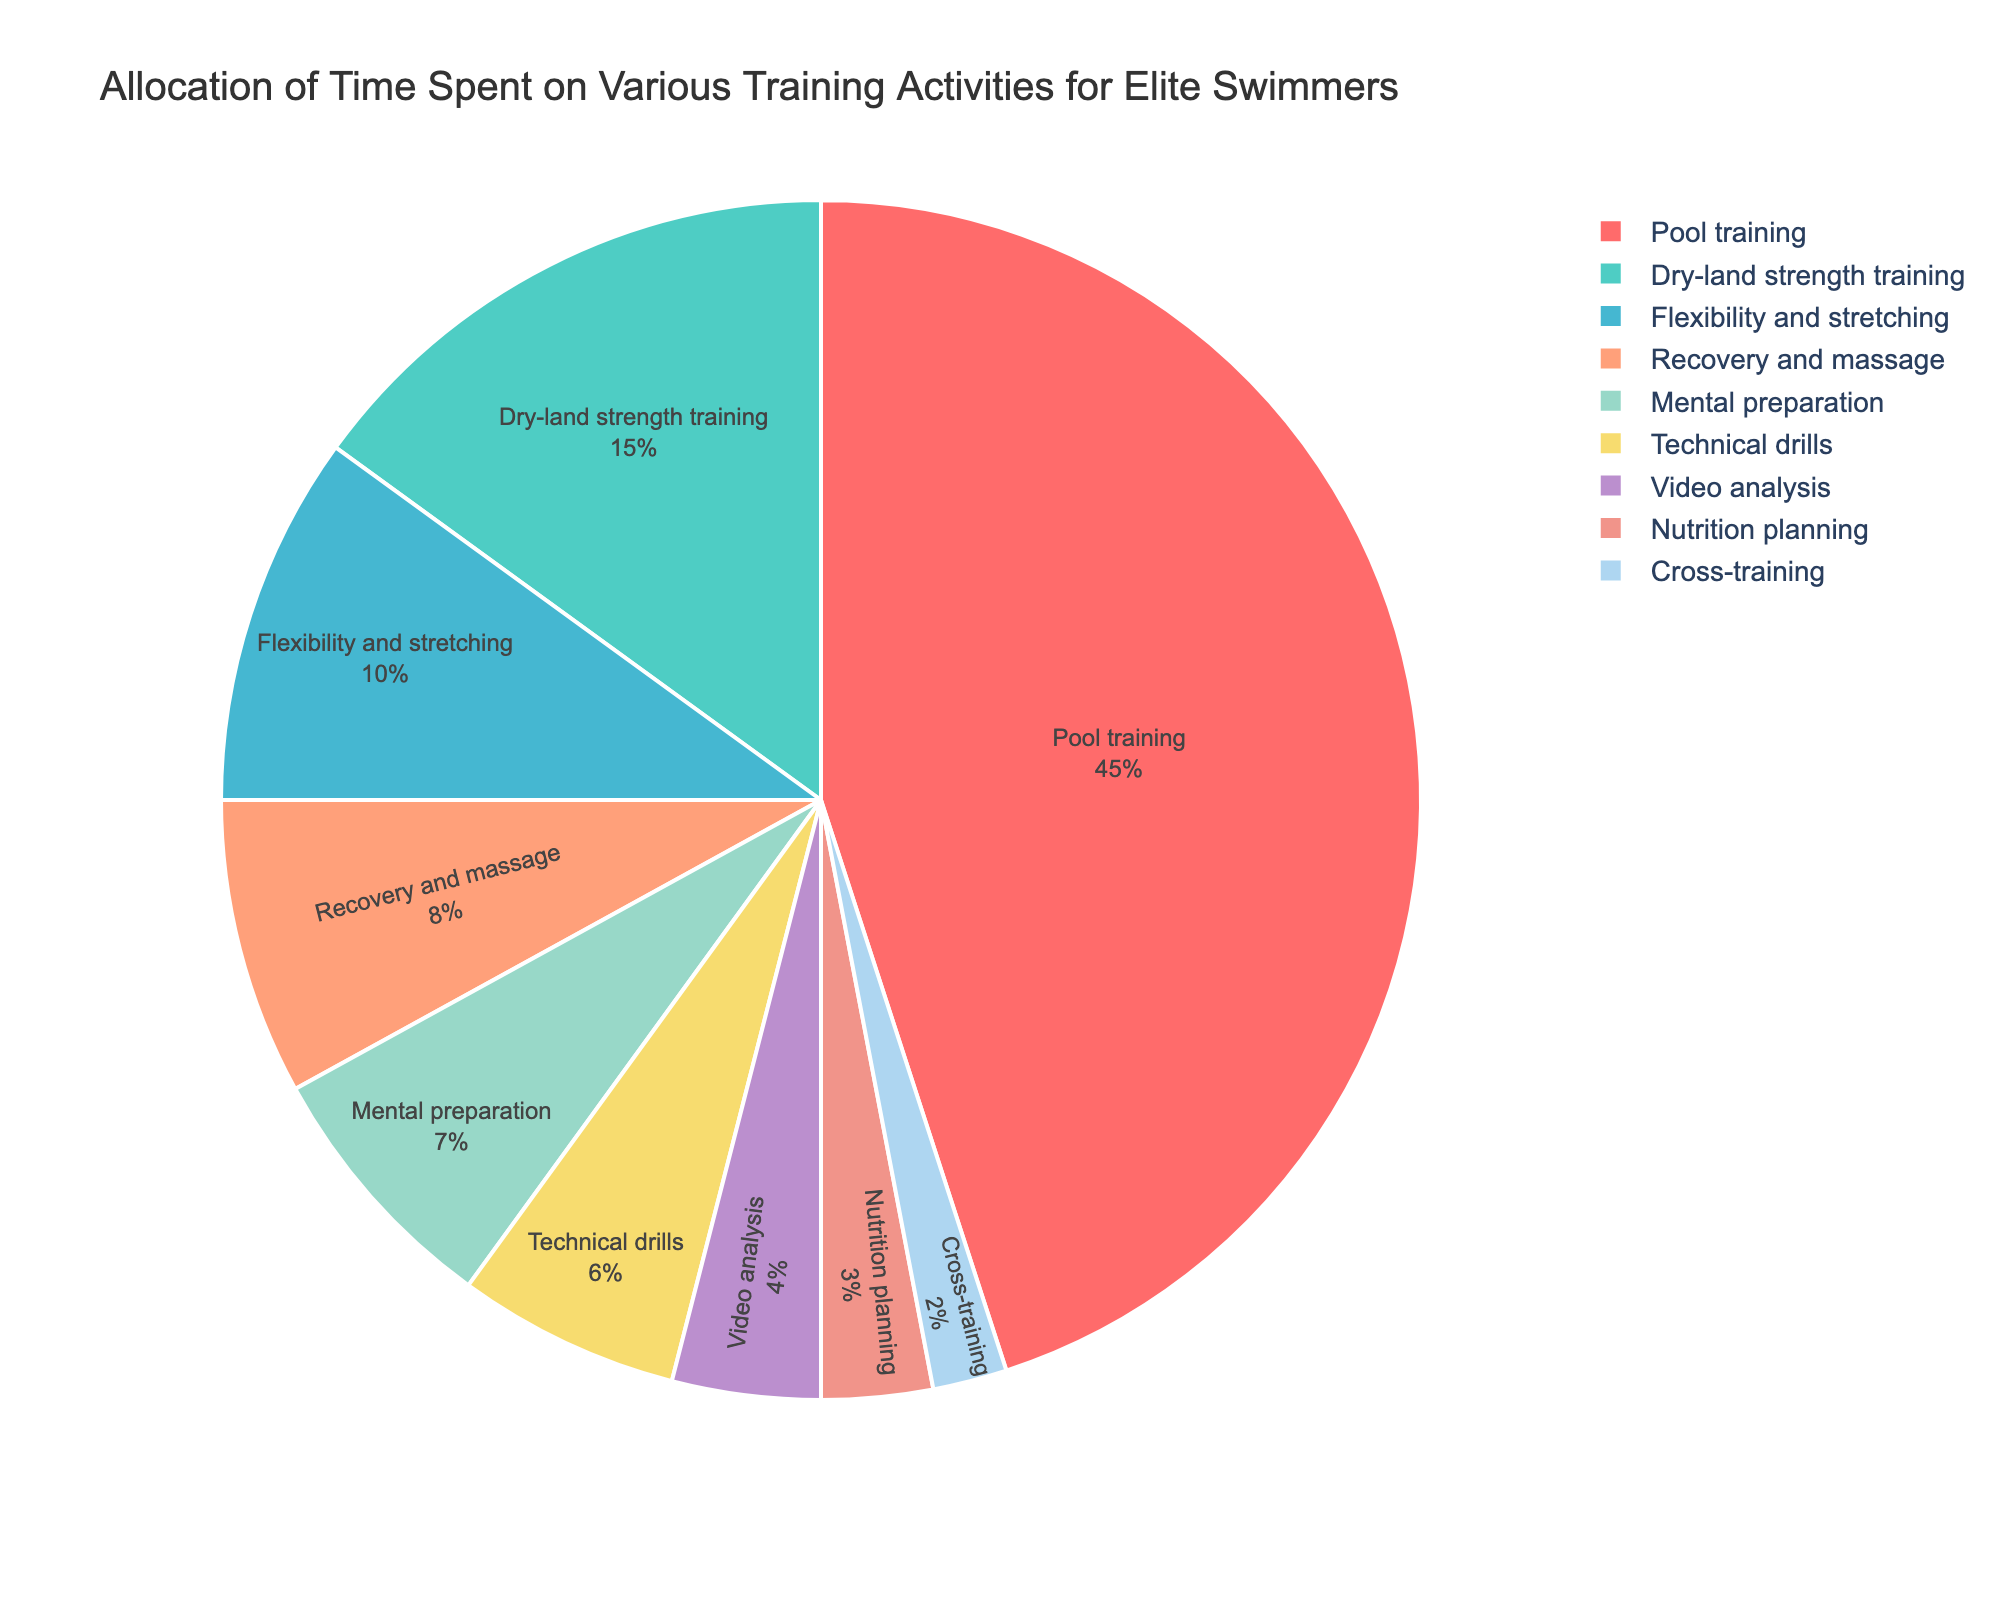what activity takes up the largest portion of training time? Pool training takes up 45% of the time, which is the largest portion in the pie chart.
Answer: Pool training What is the combined percentage of time spent on Dry-land strength training and Flexibility and stretching? The chart shows Dry-land strength training at 15% and Flexibility and stretching at 10%. Adding these together, 15% + 10% = 25%.
Answer: 25% Which activity takes up more time, Mental preparation or Video analysis? Mental preparation takes up 7% of the time while Video analysis takes up 4%. Thus, Mental preparation takes up more time.
Answer: Mental preparation Are there any activities that take up the same percentage of training time? No, each activity in the chart has a distinct percentage of time allotted to it.
Answer: No What is the smallest portion of time spent on any activity? Cross-training takes up 2% of the time, which is the smallest portion in the chart.
Answer: Cross-training What is the difference in time allocation between Recovery and massage and Nutrition planning? Recovery and massage takes up 8% and Nutrition planning takes up 3%. The difference is 8% - 3% = 5%.
Answer: 5% How much more time is spent on Pool training compared to Technical drills? Pool training takes up 45% and Technical drills take up 6%. The difference is 45% - 6% = 39%.
Answer: 39% What is the total percentage of time allocated to Recovery and massage, Mental preparation, Technical drills, and Video analysis combined? Adding up the percentages: 8% (Recovery and massage) + 7% (Mental preparation) + 6% (Technical drills) + 4% (Video analysis) = 25%.
Answer: 25% Is the time spent on Dry-land strength training more than double the time spent on Technical drills? Dry-land strength training takes up 15% and Technical drills take up 6%. Double 6% is 12%, which is less than 15%, so yes, it is more than double.
Answer: Yes 